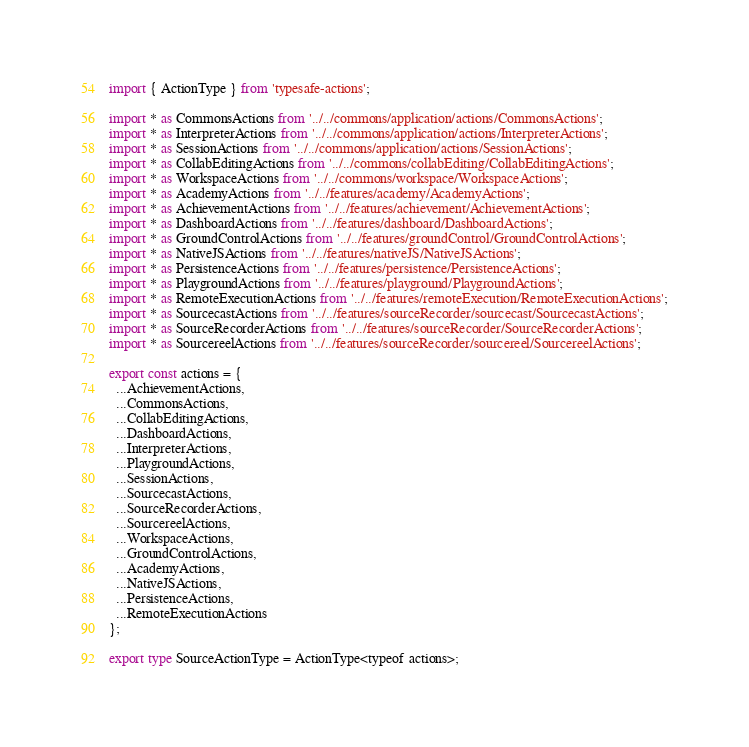<code> <loc_0><loc_0><loc_500><loc_500><_TypeScript_>import { ActionType } from 'typesafe-actions';

import * as CommonsActions from '../../commons/application/actions/CommonsActions';
import * as InterpreterActions from '../../commons/application/actions/InterpreterActions';
import * as SessionActions from '../../commons/application/actions/SessionActions';
import * as CollabEditingActions from '../../commons/collabEditing/CollabEditingActions';
import * as WorkspaceActions from '../../commons/workspace/WorkspaceActions';
import * as AcademyActions from '../../features/academy/AcademyActions';
import * as AchievementActions from '../../features/achievement/AchievementActions';
import * as DashboardActions from '../../features/dashboard/DashboardActions';
import * as GroundControlActions from '../../features/groundControl/GroundControlActions';
import * as NativeJSActions from '../../features/nativeJS/NativeJSActions';
import * as PersistenceActions from '../../features/persistence/PersistenceActions';
import * as PlaygroundActions from '../../features/playground/PlaygroundActions';
import * as RemoteExecutionActions from '../../features/remoteExecution/RemoteExecutionActions';
import * as SourcecastActions from '../../features/sourceRecorder/sourcecast/SourcecastActions';
import * as SourceRecorderActions from '../../features/sourceRecorder/SourceRecorderActions';
import * as SourcereelActions from '../../features/sourceRecorder/sourcereel/SourcereelActions';

export const actions = {
  ...AchievementActions,
  ...CommonsActions,
  ...CollabEditingActions,
  ...DashboardActions,
  ...InterpreterActions,
  ...PlaygroundActions,
  ...SessionActions,
  ...SourcecastActions,
  ...SourceRecorderActions,
  ...SourcereelActions,
  ...WorkspaceActions,
  ...GroundControlActions,
  ...AcademyActions,
  ...NativeJSActions,
  ...PersistenceActions,
  ...RemoteExecutionActions
};

export type SourceActionType = ActionType<typeof actions>;
</code> 